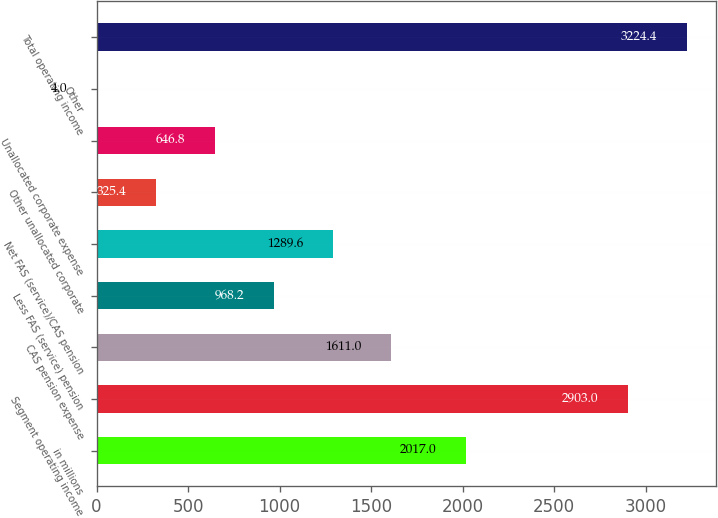<chart> <loc_0><loc_0><loc_500><loc_500><bar_chart><fcel>in millions<fcel>Segment operating income<fcel>CAS pension expense<fcel>Less FAS (service) pension<fcel>Net FAS (service)/CAS pension<fcel>Other unallocated corporate<fcel>Unallocated corporate expense<fcel>Other<fcel>Total operating income<nl><fcel>2017<fcel>2903<fcel>1611<fcel>968.2<fcel>1289.6<fcel>325.4<fcel>646.8<fcel>4<fcel>3224.4<nl></chart> 